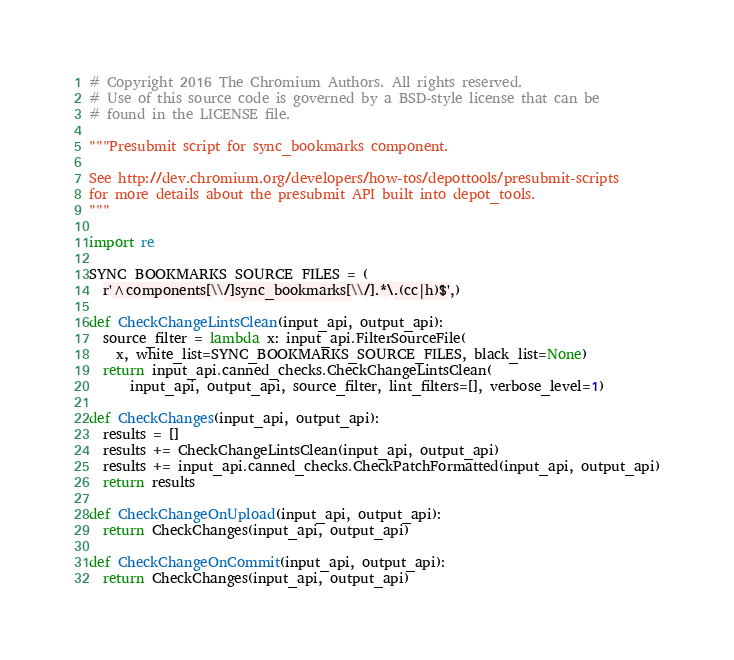Convert code to text. <code><loc_0><loc_0><loc_500><loc_500><_Python_># Copyright 2016 The Chromium Authors. All rights reserved.
# Use of this source code is governed by a BSD-style license that can be
# found in the LICENSE file.

"""Presubmit script for sync_bookmarks component.

See http://dev.chromium.org/developers/how-tos/depottools/presubmit-scripts
for more details about the presubmit API built into depot_tools.
"""

import re

SYNC_BOOKMARKS_SOURCE_FILES = (
  r'^components[\\/]sync_bookmarks[\\/].*\.(cc|h)$',)

def CheckChangeLintsClean(input_api, output_api):
  source_filter = lambda x: input_api.FilterSourceFile(
    x, white_list=SYNC_BOOKMARKS_SOURCE_FILES, black_list=None)
  return input_api.canned_checks.CheckChangeLintsClean(
      input_api, output_api, source_filter, lint_filters=[], verbose_level=1)

def CheckChanges(input_api, output_api):
  results = []
  results += CheckChangeLintsClean(input_api, output_api)
  results += input_api.canned_checks.CheckPatchFormatted(input_api, output_api)
  return results

def CheckChangeOnUpload(input_api, output_api):
  return CheckChanges(input_api, output_api)

def CheckChangeOnCommit(input_api, output_api):
  return CheckChanges(input_api, output_api)
</code> 